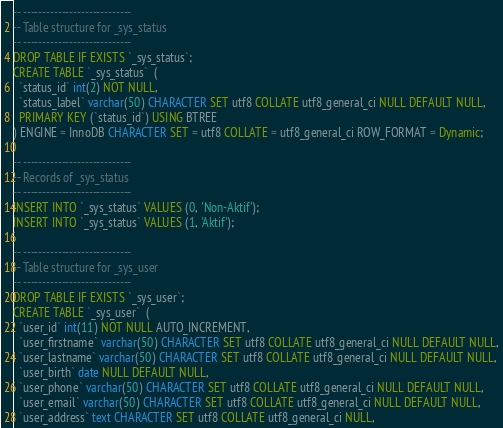<code> <loc_0><loc_0><loc_500><loc_500><_SQL_>-- ----------------------------
-- Table structure for _sys_status
-- ----------------------------
DROP TABLE IF EXISTS `_sys_status`;
CREATE TABLE `_sys_status`  (
  `status_id` int(2) NOT NULL,
  `status_label` varchar(50) CHARACTER SET utf8 COLLATE utf8_general_ci NULL DEFAULT NULL,
  PRIMARY KEY (`status_id`) USING BTREE
) ENGINE = InnoDB CHARACTER SET = utf8 COLLATE = utf8_general_ci ROW_FORMAT = Dynamic;

-- ----------------------------
-- Records of _sys_status
-- ----------------------------
INSERT INTO `_sys_status` VALUES (0, 'Non-Aktif');
INSERT INTO `_sys_status` VALUES (1, 'Aktif');

-- ----------------------------
-- Table structure for _sys_user
-- ----------------------------
DROP TABLE IF EXISTS `_sys_user`;
CREATE TABLE `_sys_user`  (
  `user_id` int(11) NOT NULL AUTO_INCREMENT,
  `user_firstname` varchar(50) CHARACTER SET utf8 COLLATE utf8_general_ci NULL DEFAULT NULL,
  `user_lastname` varchar(50) CHARACTER SET utf8 COLLATE utf8_general_ci NULL DEFAULT NULL,
  `user_birth` date NULL DEFAULT NULL,
  `user_phone` varchar(50) CHARACTER SET utf8 COLLATE utf8_general_ci NULL DEFAULT NULL,
  `user_email` varchar(50) CHARACTER SET utf8 COLLATE utf8_general_ci NULL DEFAULT NULL,
  `user_address` text CHARACTER SET utf8 COLLATE utf8_general_ci NULL,</code> 